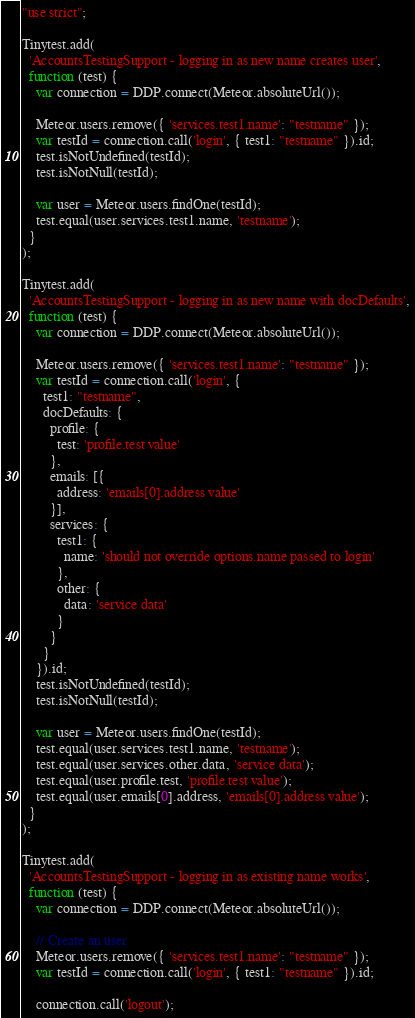<code> <loc_0><loc_0><loc_500><loc_500><_JavaScript_>"use strict";

Tinytest.add(
  'AccountsTestingSupport - logging in as new name creates user',
  function (test) {
    var connection = DDP.connect(Meteor.absoluteUrl());

    Meteor.users.remove({ 'services.test1.name': "testname" });
    var testId = connection.call('login', { test1: "testname" }).id;
    test.isNotUndefined(testId);
    test.isNotNull(testId);

    var user = Meteor.users.findOne(testId);
    test.equal(user.services.test1.name, 'testname');
  }
);

Tinytest.add(
  'AccountsTestingSupport - logging in as new name with docDefaults',
  function (test) {
    var connection = DDP.connect(Meteor.absoluteUrl());

    Meteor.users.remove({ 'services.test1.name': "testname" });
    var testId = connection.call('login', {
      test1: "testname",
      docDefaults: {
        profile: {
          test: 'profile.test value'
        },
        emails: [{
          address: 'emails[0].address value'
        }],
        services: {
          test1: {
            name: 'should not override options.name passed to login'
          },
          other: {
            data: 'service data'
          }          
        }
      }
    }).id;
    test.isNotUndefined(testId);
    test.isNotNull(testId);

    var user = Meteor.users.findOne(testId);
    test.equal(user.services.test1.name, 'testname');
    test.equal(user.services.other.data, 'service data');
    test.equal(user.profile.test, 'profile.test value');
    test.equal(user.emails[0].address, 'emails[0].address value');
  }
);

Tinytest.add(
  'AccountsTestingSupport - logging in as existing name works',
  function (test) {
    var connection = DDP.connect(Meteor.absoluteUrl());

    // Create an user
    Meteor.users.remove({ 'services.test1.name': "testname" });
    var testId = connection.call('login', { test1: "testname" }).id;

    connection.call('logout');</code> 